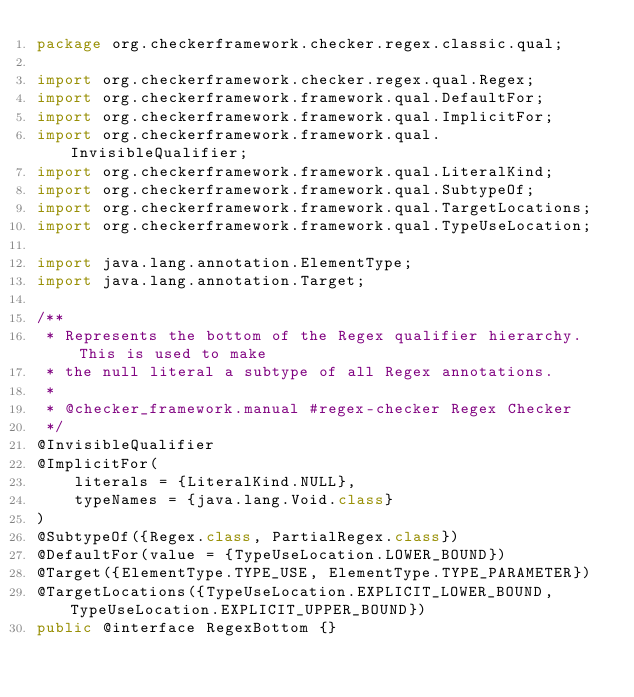<code> <loc_0><loc_0><loc_500><loc_500><_Java_>package org.checkerframework.checker.regex.classic.qual;

import org.checkerframework.checker.regex.qual.Regex;
import org.checkerframework.framework.qual.DefaultFor;
import org.checkerframework.framework.qual.ImplicitFor;
import org.checkerframework.framework.qual.InvisibleQualifier;
import org.checkerframework.framework.qual.LiteralKind;
import org.checkerframework.framework.qual.SubtypeOf;
import org.checkerframework.framework.qual.TargetLocations;
import org.checkerframework.framework.qual.TypeUseLocation;

import java.lang.annotation.ElementType;
import java.lang.annotation.Target;

/**
 * Represents the bottom of the Regex qualifier hierarchy. This is used to make
 * the null literal a subtype of all Regex annotations.
 *
 * @checker_framework.manual #regex-checker Regex Checker
 */
@InvisibleQualifier
@ImplicitFor(
    literals = {LiteralKind.NULL},
    typeNames = {java.lang.Void.class}
)
@SubtypeOf({Regex.class, PartialRegex.class})
@DefaultFor(value = {TypeUseLocation.LOWER_BOUND})
@Target({ElementType.TYPE_USE, ElementType.TYPE_PARAMETER})
@TargetLocations({TypeUseLocation.EXPLICIT_LOWER_BOUND, TypeUseLocation.EXPLICIT_UPPER_BOUND})
public @interface RegexBottom {}
</code> 